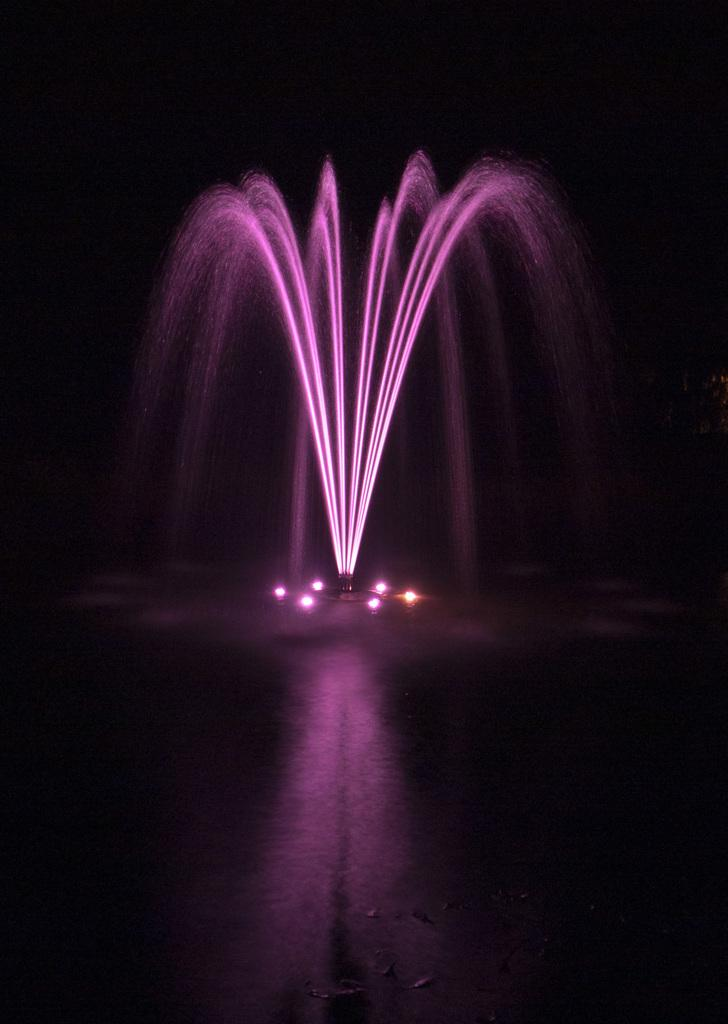What is the main subject of the image? The main subject of the image is a water fountain. Are there any special features on the water fountain? Yes, the water fountain has lights on it. Where is the water fountain located in the image? The water fountain is in the center of the image. What type of butter is being used to grease the head of the cable in the image? There is no butter, head, or cable present in the image. 